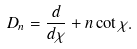Convert formula to latex. <formula><loc_0><loc_0><loc_500><loc_500>D _ { n } = \frac { d } { d \chi } + n \cot \chi .</formula> 